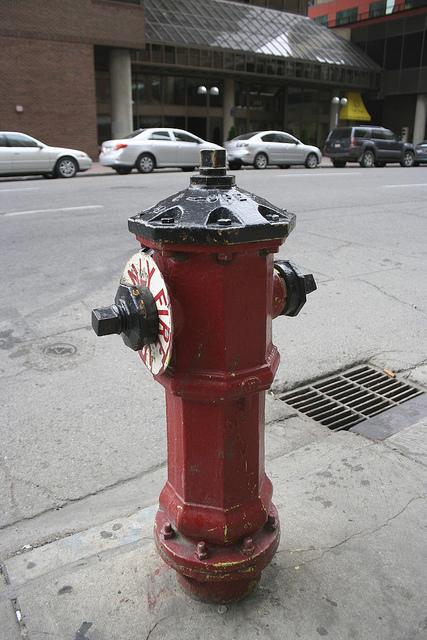What is the safety device in the foreground used to help defeat? Please explain your reasoning. fires. These hydrants are used by firefighters. 